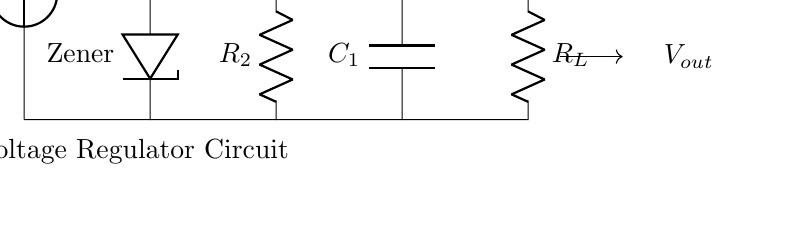What is the input voltage of the circuit? The input voltage is denoted as V_in in the circuit diagram. It's the voltage supplied to the circuit from an external power source.
Answer: V_in What type of diode is used in this circuit? The Zener diode, labeled as Zener in the circuit diagram, is specifically designed for voltage regulation, allowing reverse current flow to stabilize output voltage.
Answer: Zener What is the purpose of resistor R_2? Resistor R_2 is used in the voltage regulator to limit the current through the Zener diode and help regulate the output voltage to the desired level.
Answer: Current limiting How does the capacitor C_1 affect the circuit? The capacitor C_1 smooths out the voltage output fluctuations by filtering any ripples, which helps maintain a stable output voltage for the assistive device.
Answer: Stabilization What is the function of the load resistor R_L? The load resistor R_L represents the assistive device that will draw current, allowing us to see how the voltage regulator performs under load conditions.
Answer: Load representation 